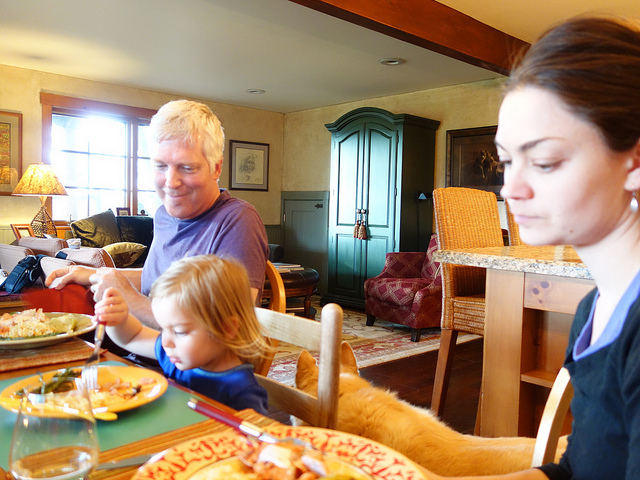Can you describe the meal that the family appears to be having? The family appears to be enjoying a cozy, home-cooked meal. On the table, there are plates with what looks like a variety of foods, potentially including vegetables and meat, suggesting a balanced meal. The colorful plates add a welcoming and warm atmosphere to the dining experience. 